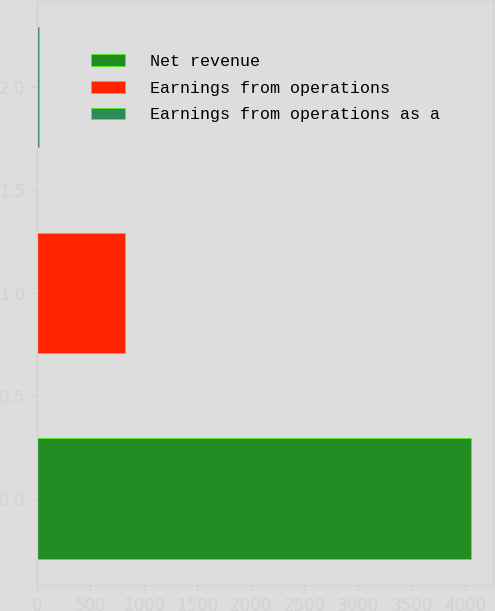<chart> <loc_0><loc_0><loc_500><loc_500><bar_chart><fcel>Net revenue<fcel>Earnings from operations<fcel>Earnings from operations as a<nl><fcel>4060<fcel>827<fcel>20.4<nl></chart> 